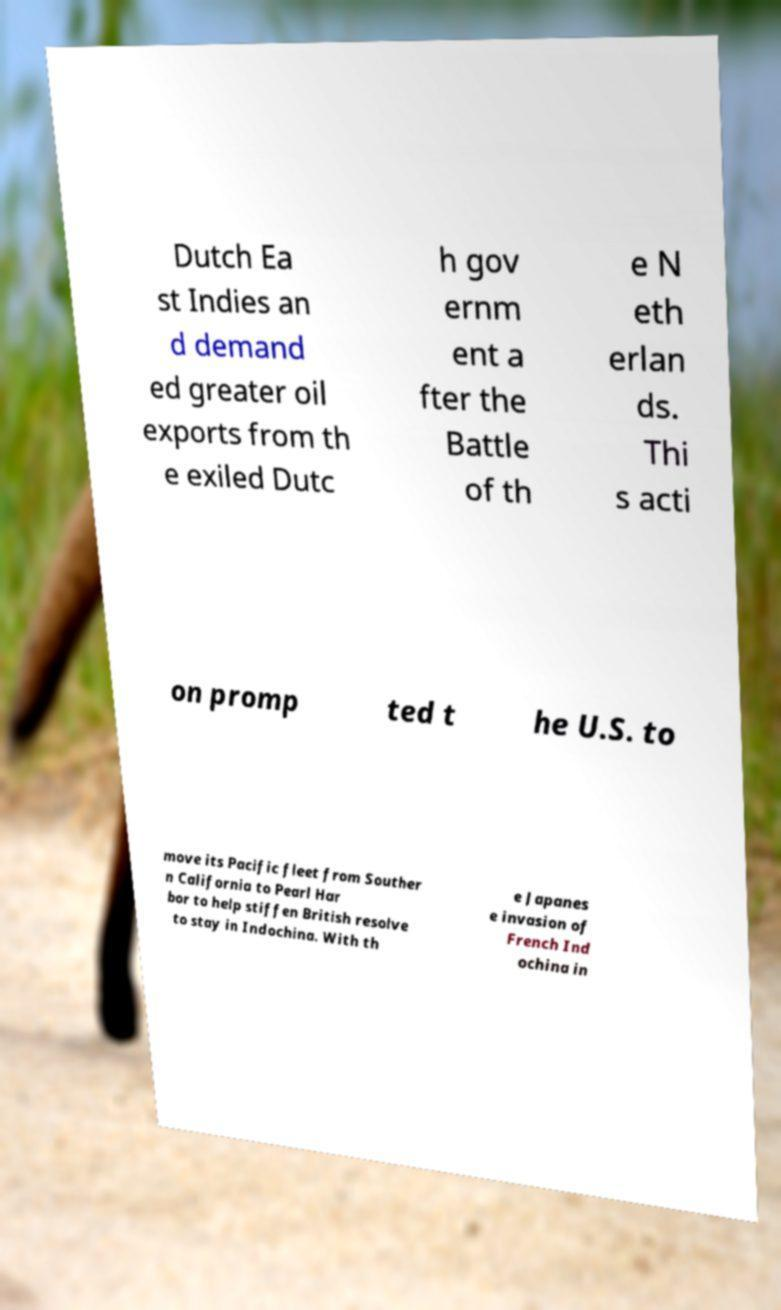Can you read and provide the text displayed in the image?This photo seems to have some interesting text. Can you extract and type it out for me? Dutch Ea st Indies an d demand ed greater oil exports from th e exiled Dutc h gov ernm ent a fter the Battle of th e N eth erlan ds. Thi s acti on promp ted t he U.S. to move its Pacific fleet from Souther n California to Pearl Har bor to help stiffen British resolve to stay in Indochina. With th e Japanes e invasion of French Ind ochina in 